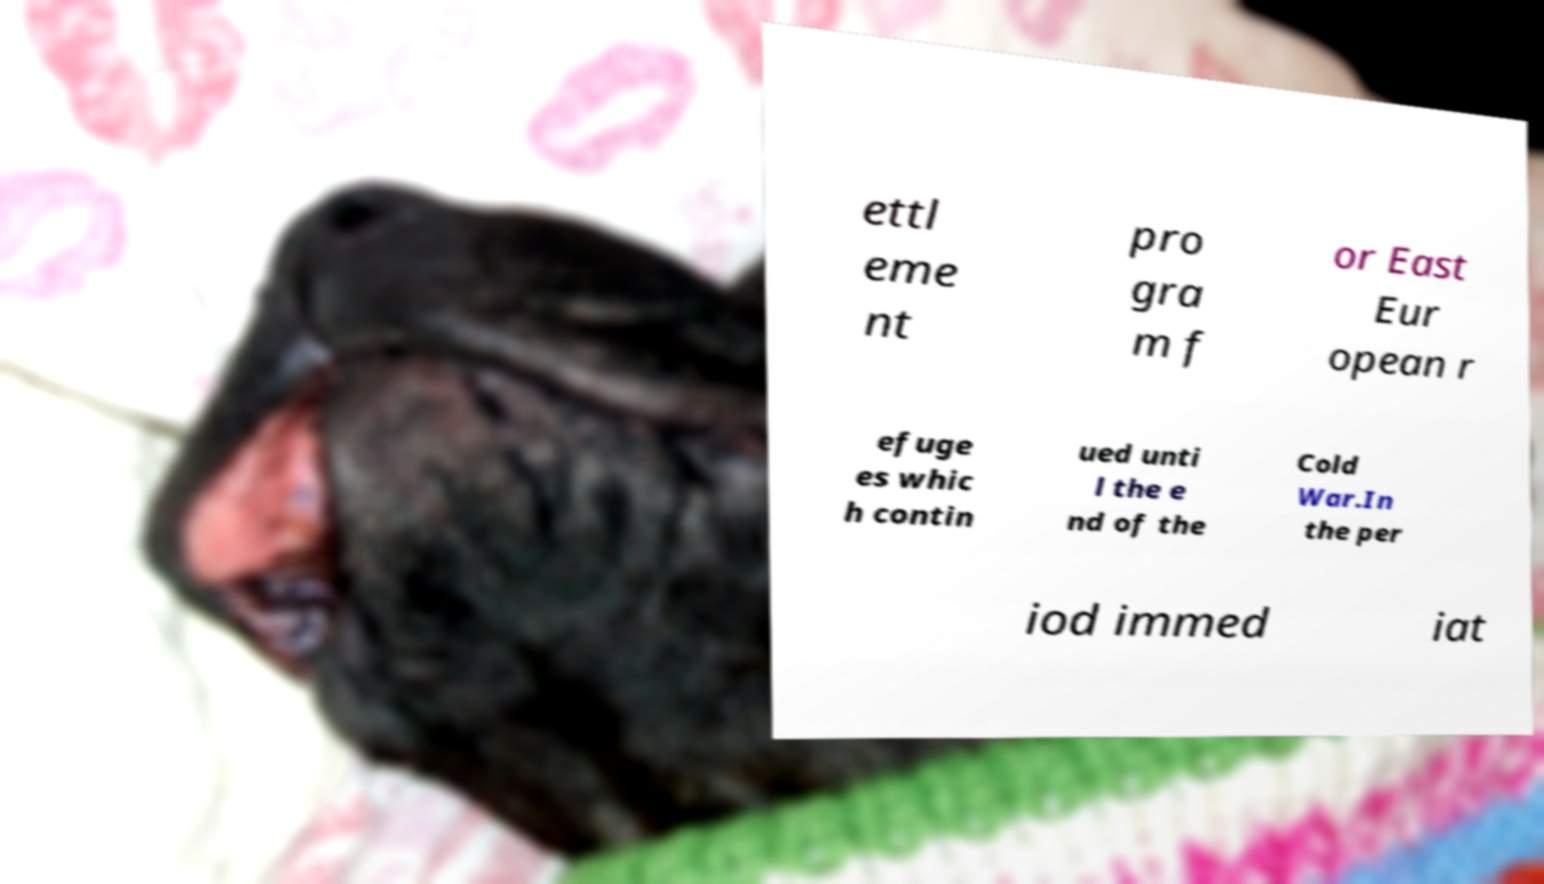Could you assist in decoding the text presented in this image and type it out clearly? ettl eme nt pro gra m f or East Eur opean r efuge es whic h contin ued unti l the e nd of the Cold War.In the per iod immed iat 